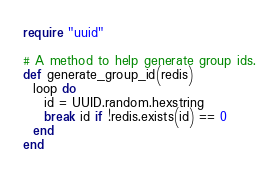<code> <loc_0><loc_0><loc_500><loc_500><_Crystal_>require "uuid"

# A method to help generate group ids.
def generate_group_id(redis)
  loop do
    id = UUID.random.hexstring
    break id if !redis.exists(id) == 0
  end
end
</code> 